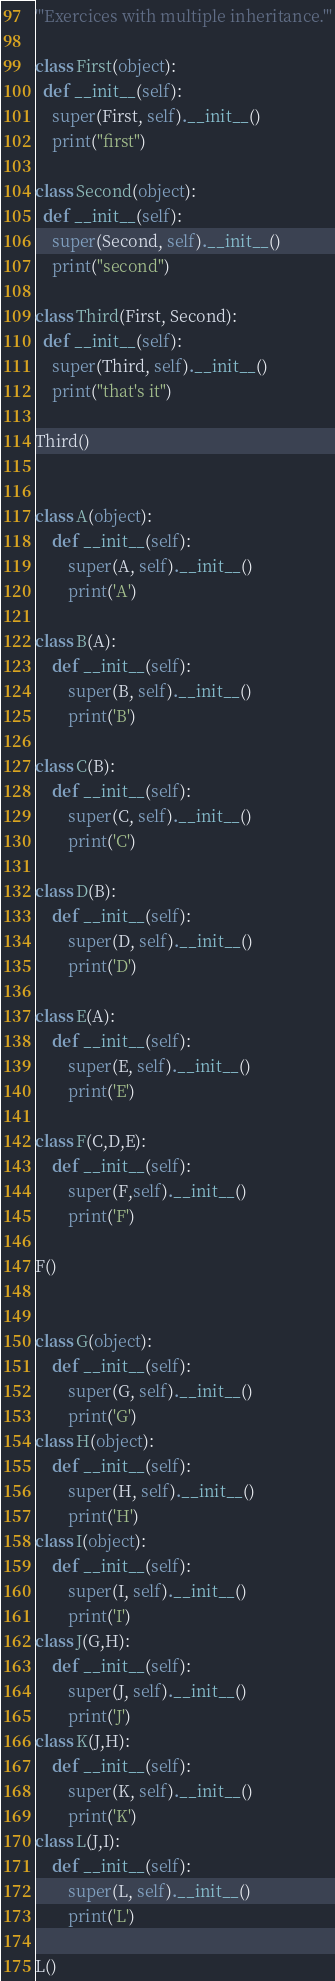<code> <loc_0><loc_0><loc_500><loc_500><_Python_>'''Exercices with multiple inheritance.'''

class First(object):
  def __init__(self):
    super(First, self).__init__()
    print("first")

class Second(object):
  def __init__(self):
    super(Second, self).__init__()
    print("second")

class Third(First, Second):
  def __init__(self):
    super(Third, self).__init__()
    print("that's it")

Third()


class A(object):
    def __init__(self):
        super(A, self).__init__()
        print('A')

class B(A):
    def __init__(self):
        super(B, self).__init__()
        print('B')

class C(B):
    def __init__(self):
        super(C, self).__init__()
        print('C')

class D(B):
    def __init__(self):
        super(D, self).__init__()
        print('D')

class E(A):
    def __init__(self):
        super(E, self).__init__()
        print('E')

class F(C,D,E):
    def __init__(self):
        super(F,self).__init__()
        print('F')

F()


class G(object):
    def __init__(self):
        super(G, self).__init__()
        print('G')
class H(object):
    def __init__(self):
        super(H, self).__init__()
        print('H')
class I(object):
    def __init__(self):
        super(I, self).__init__()
        print('I')
class J(G,H):
    def __init__(self):
        super(J, self).__init__()
        print('J')
class K(J,H):
    def __init__(self):
        super(K, self).__init__()
        print('K')
class L(J,I):
    def __init__(self):
        super(L, self).__init__()
        print('L')

L()





</code> 